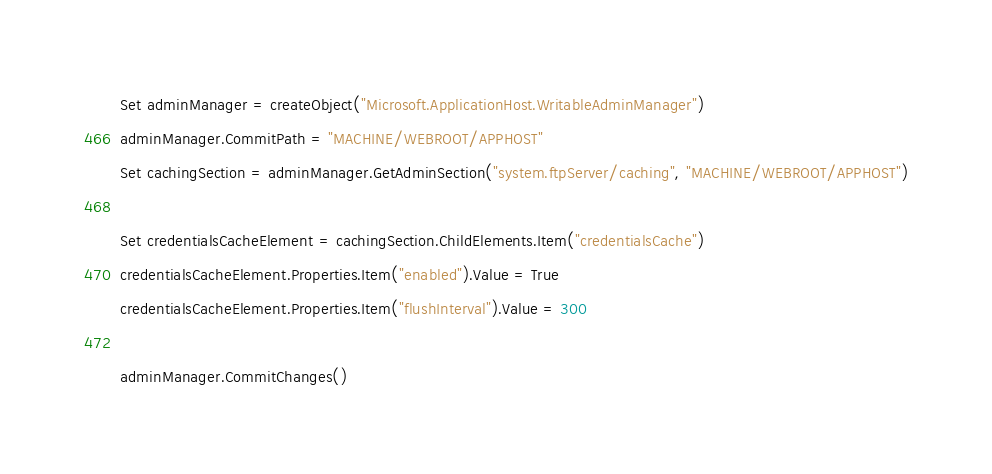Convert code to text. <code><loc_0><loc_0><loc_500><loc_500><_VisualBasic_>Set adminManager = createObject("Microsoft.ApplicationHost.WritableAdminManager")
adminManager.CommitPath = "MACHINE/WEBROOT/APPHOST"
Set cachingSection = adminManager.GetAdminSection("system.ftpServer/caching", "MACHINE/WEBROOT/APPHOST")

Set credentialsCacheElement = cachingSection.ChildElements.Item("credentialsCache")
credentialsCacheElement.Properties.Item("enabled").Value = True
credentialsCacheElement.Properties.Item("flushInterval").Value = 300

adminManager.CommitChanges()</code> 